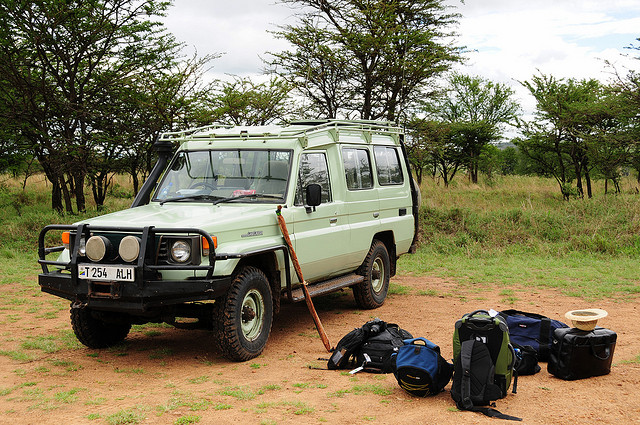Identify the text contained in this image. 254 ALH 